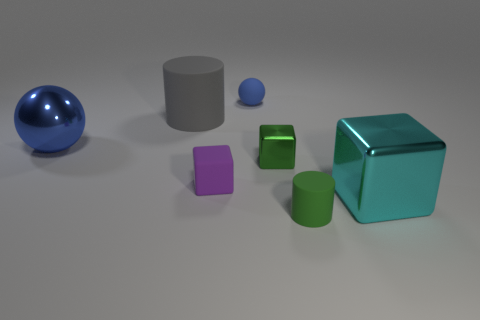Subtract all tiny blocks. How many blocks are left? 1 Add 2 large cyan objects. How many objects exist? 9 Subtract all cylinders. How many objects are left? 5 Add 5 tiny yellow matte things. How many tiny yellow matte things exist? 5 Subtract 0 red cylinders. How many objects are left? 7 Subtract all small blue matte objects. Subtract all green cylinders. How many objects are left? 5 Add 2 objects. How many objects are left? 9 